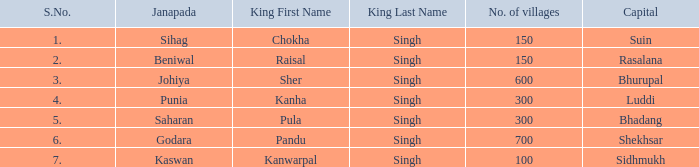What is the highest S number with a capital of Shekhsar? 6.0. Parse the table in full. {'header': ['S.No.', 'Janapada', 'King First Name', 'King Last Name', 'No. of villages', 'Capital'], 'rows': [['1.', 'Sihag', 'Chokha', 'Singh', '150', 'Suin'], ['2.', 'Beniwal', 'Raisal', 'Singh', '150', 'Rasalana'], ['3.', 'Johiya', 'Sher', 'Singh', '600', 'Bhurupal'], ['4.', 'Punia', 'Kanha', 'Singh', '300', 'Luddi'], ['5.', 'Saharan', 'Pula', 'Singh', '300', 'Bhadang'], ['6.', 'Godara', 'Pandu', 'Singh', '700', 'Shekhsar'], ['7.', 'Kaswan', 'Kanwarpal', 'Singh', '100', 'Sidhmukh']]} 